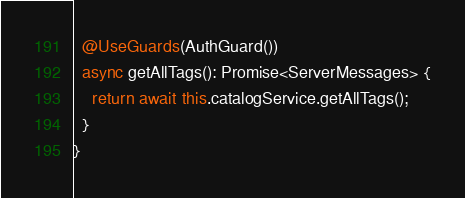<code> <loc_0><loc_0><loc_500><loc_500><_TypeScript_>  @UseGuards(AuthGuard())
  async getAllTags(): Promise<ServerMessages> {
    return await this.catalogService.getAllTags();
  }
}
</code> 